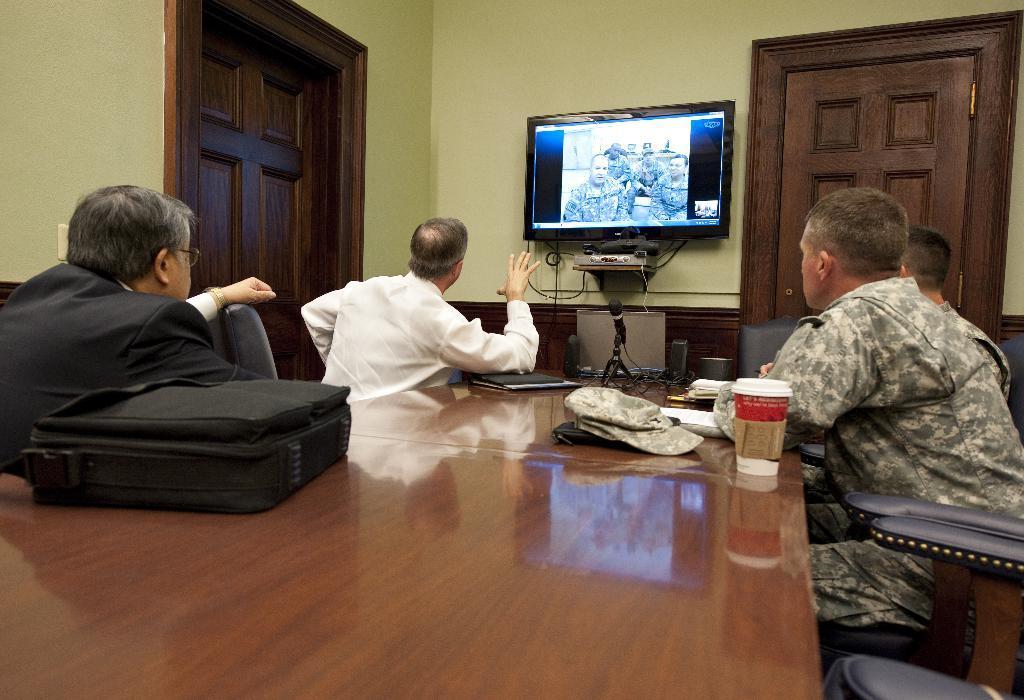Can you describe this image briefly? In this image i can see few people sitting on chairs around the table. On the table i can see a suitcase, a cap, a cup, a laptop and a microphone. In the background i can see the wall, a door,a television screen and a router. 